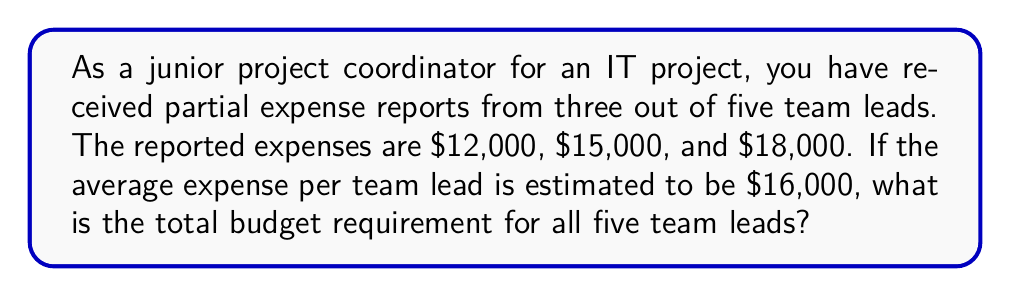Show me your answer to this math problem. Let's approach this step-by-step:

1) First, we need to calculate the total reported expenses:
   $12,000 + $15,000 + $18,000 = $45,000

2) We know that these expenses are from 3 out of 5 team leads.

3) The average expense per team lead is estimated to be $16,000.

4) To find the total budget requirement, we need to calculate:
   (Reported expenses) + (Estimated expenses for unreported team leads)

5) The number of unreported team leads is: 5 - 3 = 2

6) Estimated expenses for unreported team leads:
   $16,000 × 2 = $32,000

7) Total budget requirement:
   $45,000 + $32,000 = $77,000

We can express this mathematically as:

$$\text{Total Budget} = \sum_{i=1}^{n} R_i + (T - n) \times A$$

Where:
$R_i$ = Reported expenses
$T$ = Total number of team leads
$n$ = Number of team leads who reported
$A$ = Average estimated expense per team lead

Plugging in our values:

$$\text{Total Budget} = (12000 + 15000 + 18000) + (5 - 3) \times 16000 = 77000$$
Answer: $77,000 